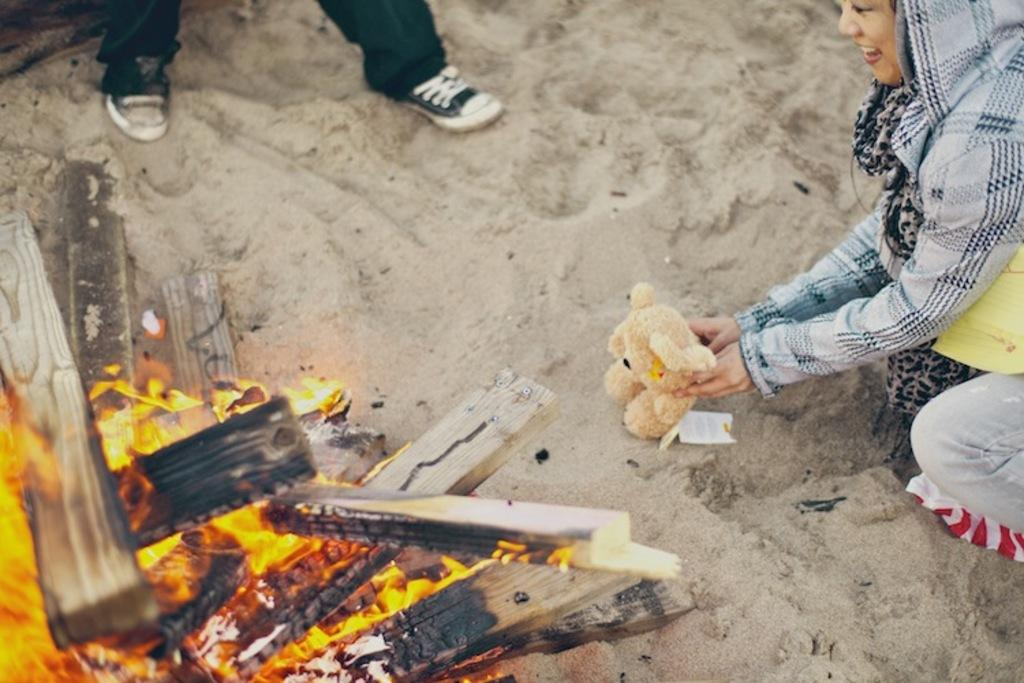What is the main feature of the image? There is a bonfire on the sand in the image. What is the girl in the image doing? The girl is sitting on the sand. What is the girl holding in the image? The girl is holding a teddy bear. Can you describe the presence of other people in the image? There are legs of a person visible in the image. Is there a stream of water flowing near the bonfire in the image? No, there is no stream of water visible in the image. 